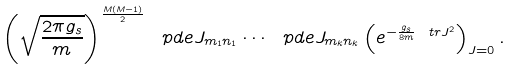Convert formula to latex. <formula><loc_0><loc_0><loc_500><loc_500>\left ( \sqrt { \frac { 2 \pi g _ { s } } { m } } \right ) ^ { \frac { M ( M - 1 ) } { 2 } } \ p d e { J _ { m _ { 1 } n _ { 1 } } } \cdots \ p d e { J _ { m _ { k } n _ { k } } } \left ( e ^ { - \frac { g _ { s } } { 8 m } \ t r J ^ { 2 } } \right ) _ { J = 0 } .</formula> 